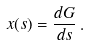Convert formula to latex. <formula><loc_0><loc_0><loc_500><loc_500>x ( s ) = \frac { d G } { d s } \, .</formula> 